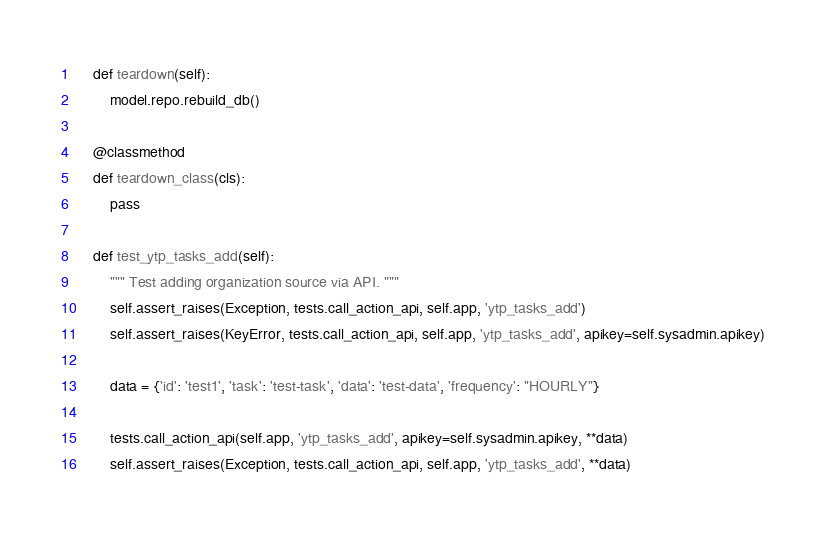<code> <loc_0><loc_0><loc_500><loc_500><_Python_>    def teardown(self):
        model.repo.rebuild_db()

    @classmethod
    def teardown_class(cls):
        pass

    def test_ytp_tasks_add(self):
        """ Test adding organization source via API. """
        self.assert_raises(Exception, tests.call_action_api, self.app, 'ytp_tasks_add')
        self.assert_raises(KeyError, tests.call_action_api, self.app, 'ytp_tasks_add', apikey=self.sysadmin.apikey)

        data = {'id': 'test1', 'task': 'test-task', 'data': 'test-data', 'frequency': "HOURLY"}

        tests.call_action_api(self.app, 'ytp_tasks_add', apikey=self.sysadmin.apikey, **data)
        self.assert_raises(Exception, tests.call_action_api, self.app, 'ytp_tasks_add', **data)
</code> 